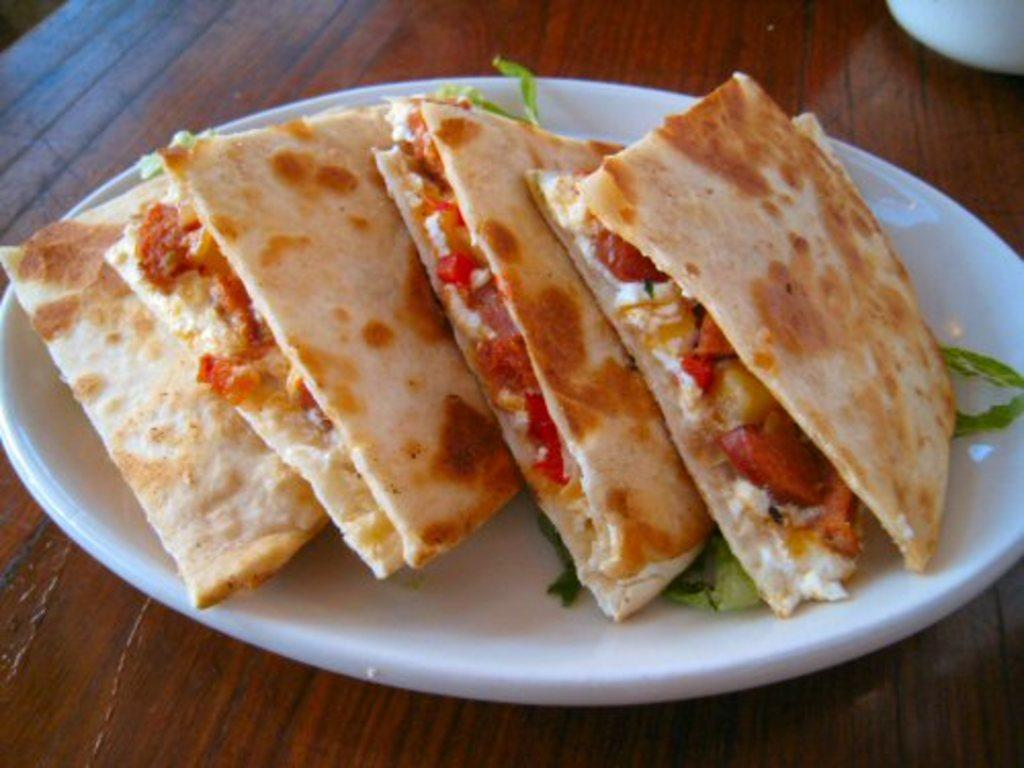What type of surface is visible in the image? There is a wooden surface in the image. What is placed on the wooden surface? There is a plate with food items on the wooden surface. Can you describe the partially covered object in the top right corner of the image? Unfortunately, the object is partially covered, so it is difficult to provide a detailed description. What direction is the knowledge flowing in the image? There is no knowledge present in the image, so it is not possible to determine the direction of its flow. 